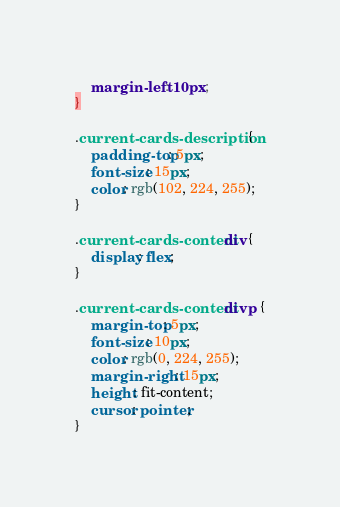<code> <loc_0><loc_0><loc_500><loc_500><_CSS_>    margin-left: 10px;
}

.current-cards-description {
    padding-top: 5px;
    font-size: 15px;
    color: rgb(102, 224, 255);
}

.current-cards-content div {
    display: flex;
}

.current-cards-content div p {
    margin-top: 5px;
    font-size: 10px;
    color: rgb(0, 224, 255);
    margin-right: 15px;
    height: fit-content;
    cursor: pointer;
}</code> 